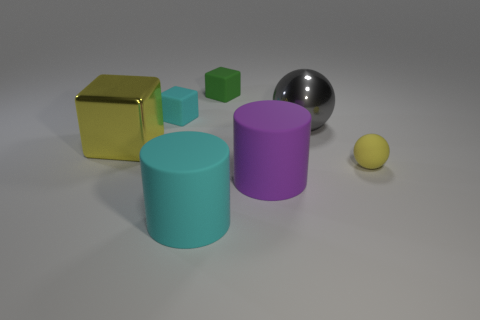Are there fewer large gray metallic balls that are to the right of the big shiny sphere than cyan rubber things to the right of the cyan cube?
Make the answer very short. Yes. There is a large metal object in front of the gray ball; does it have the same color as the ball in front of the big gray shiny sphere?
Your response must be concise. Yes. Are there any cyan things that have the same material as the large yellow cube?
Keep it short and to the point. No. What is the size of the yellow object left of the large metal thing that is to the right of the purple cylinder?
Keep it short and to the point. Large. Is the number of big yellow things greater than the number of small blue metallic objects?
Provide a short and direct response. Yes. There is a sphere behind the yellow sphere; is its size the same as the purple thing?
Offer a very short reply. Yes. How many big spheres have the same color as the big cube?
Provide a succinct answer. 0. Do the small yellow matte object and the tiny cyan thing have the same shape?
Your answer should be very brief. No. Are there any other things that have the same size as the rubber ball?
Ensure brevity in your answer.  Yes. What size is the other matte thing that is the same shape as the large cyan rubber thing?
Your answer should be very brief. Large. 